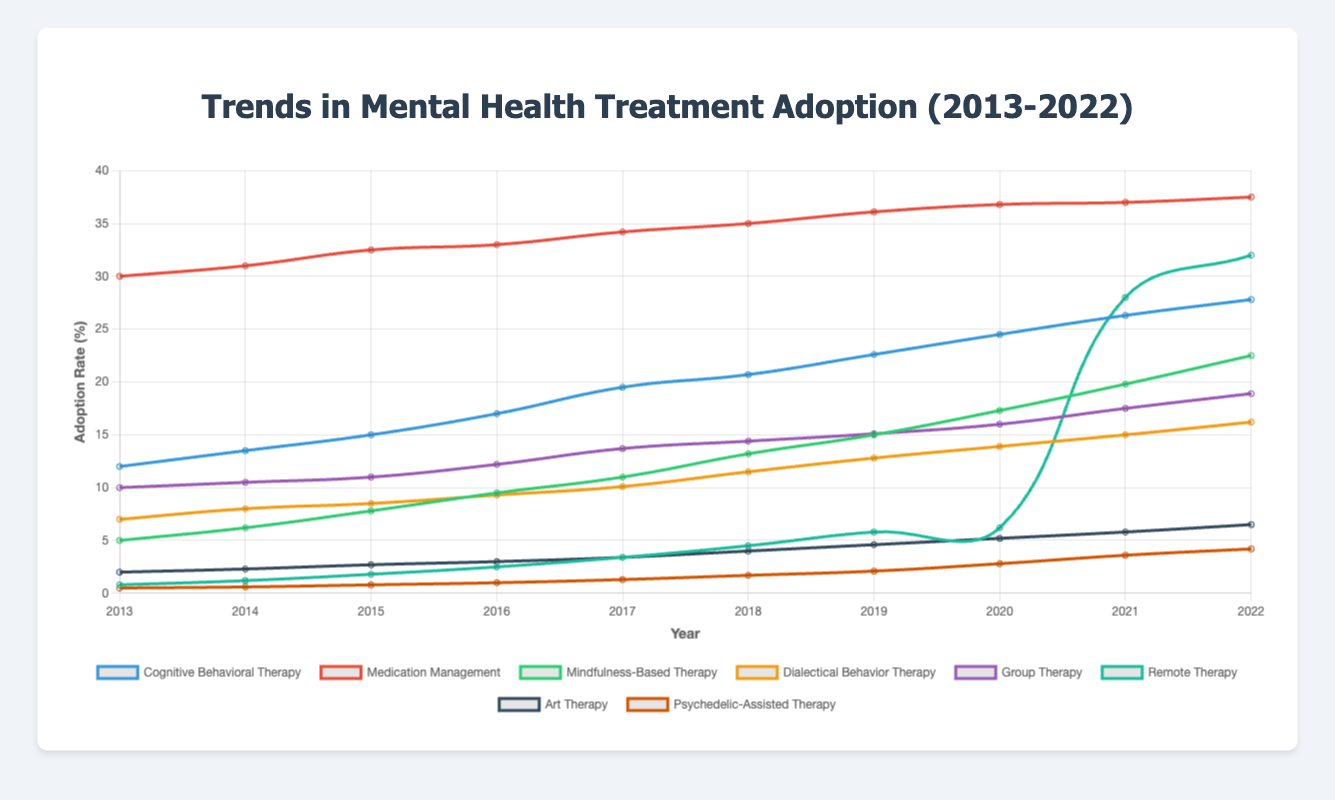Which therapy type had the highest adoption rate in 2022? To determine this, look at the y-axis value for each line at the year 2022. Identify the line that reaches the highest point.
Answer: Medication Management How did the adoption rate of Remote Therapy change from 2020 to 2021? Compare the adoption rates of Remote Therapy between the years 2020 and 2021 by locating the y-axis values for these years. Subtract the 2020 value from the 2021 value.
Answer: Increased by 21.8% What was the combined adoption rate of Cognitive Behavioral Therapy and Mindfulness-Based Therapy in 2017? Find the adoption rates for Cognitive Behavioral Therapy and Mindfulness-Based Therapy in 2017, then sum them. Cognitive Behavioral Therapy: 19.5%, Mindfulness-Based Therapy: 11%, combined adoption rate: 19.5 + 11
Answer: 30.5% Which therapy type showed the most significant increase in adoption rate from 2019 to 2020? Look at the difference in y-axis values for each therapy type between 2019 and 2020. The therapy type with the largest change is Remote Therapy, with an increase from 5.8% to 28%.
Answer: Remote Therapy What color represents Mindfulness-Based Therapy in the chart? Identify the color of the line representing Mindfulness-Based Therapy by checking the legend, where each therapy type is associated with a specific color.
Answer: Green Which therapy had a higher adoption rate in 2015, Group Therapy or Dialectical Behavior Therapy? Compare the y-axis values for Group Therapy and Dialectical Behavior Therapy in 2015. Group Therapy: 11%, Dialectical Behavior Therapy: 8.5%.
Answer: Group Therapy Between which years did Cognitive Behavioral Therapy see the greatest increase in adoption rate? Determine the adoption rates for Cognitive Behavioral Therapy in consecutive years and find the pair of years with the largest difference. The greatest increase was between 2014-2015 (1.5%).
Answer: 2014-2015 How many years did it take for Cognitive Behavioral Therapy to more than double its adoption rate from the initial value in 2013? Cognitive Behavioral Therapy's adoption rate in 2013 was 12%. More than double would be greater than 24%. Check when this value is first exceeded.
Answer: 7 years (reached in 2020) What's the average adoption rate of Psychedelic-Assisted Therapy over the decade shown? Sum the adoption rates for Psychedelic-Assisted Therapy from 2013 to 2022 and divide by the number of years (10). Sum: 0.5 + 0.6 + 0.8 + 1 + 1.3 + 1.7 + 2.1 + 2.8 + 3.6 + 4.2 = 18.6; Average: 18.6 / 10
Answer: 1.86% In which year did Art Therapy see the smallest increase in adoption rate compared to the previous year? Calculate the yearly increase for Art Therapy's adoption rate and identify the year with the smallest increase. Comparisons: 0.3 (2014), 0.4 (2015), 0.3 (2016), 0.4 (2017), 0.6 (2018), 0.6 (2019), 0.6 (2020), 0.6 (2021), 0.7 (2022).
Answer: 2014 and 2016 (both 0.3%) 